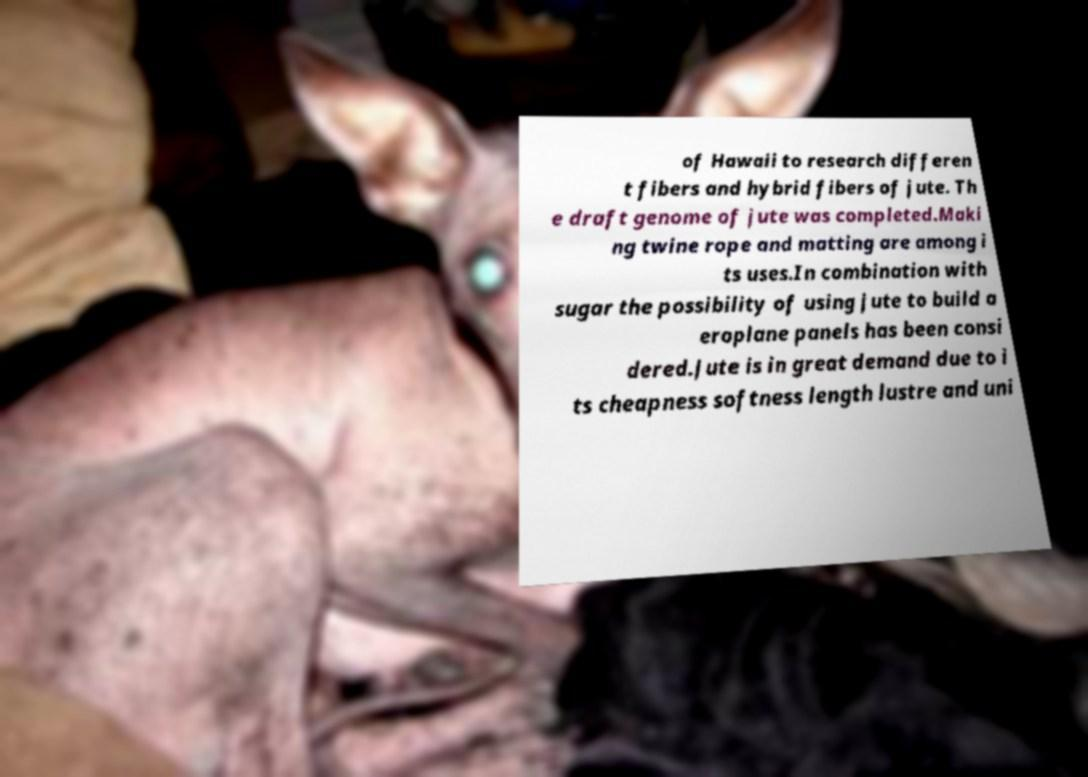Can you accurately transcribe the text from the provided image for me? of Hawaii to research differen t fibers and hybrid fibers of jute. Th e draft genome of jute was completed.Maki ng twine rope and matting are among i ts uses.In combination with sugar the possibility of using jute to build a eroplane panels has been consi dered.Jute is in great demand due to i ts cheapness softness length lustre and uni 